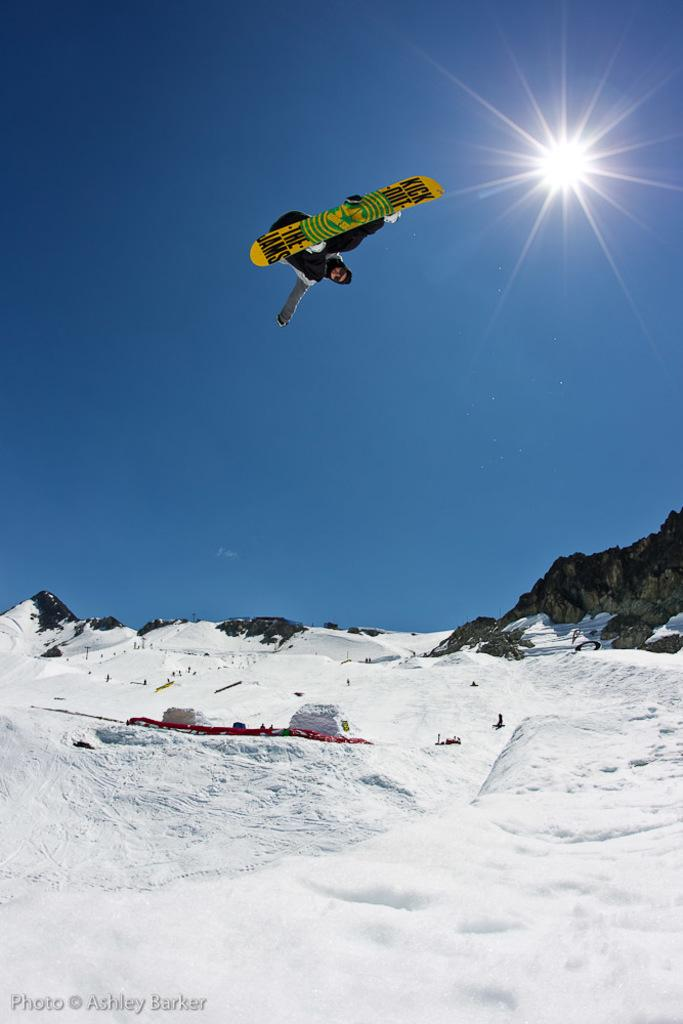Who or what is the main subject in the image? There is a person in the image. What is the person doing in the image? The person is on a skateboard. What is the weather like in the image? There is snow in the image, which suggests a cold or wintery environment. What is the condition of the sky in the image? The sky is clear in the image. What type of pets can be seen playing with a fang in the image? There are no pets or fangs present in the image; it features a person on a skateboard in a snowy environment with a clear sky. 